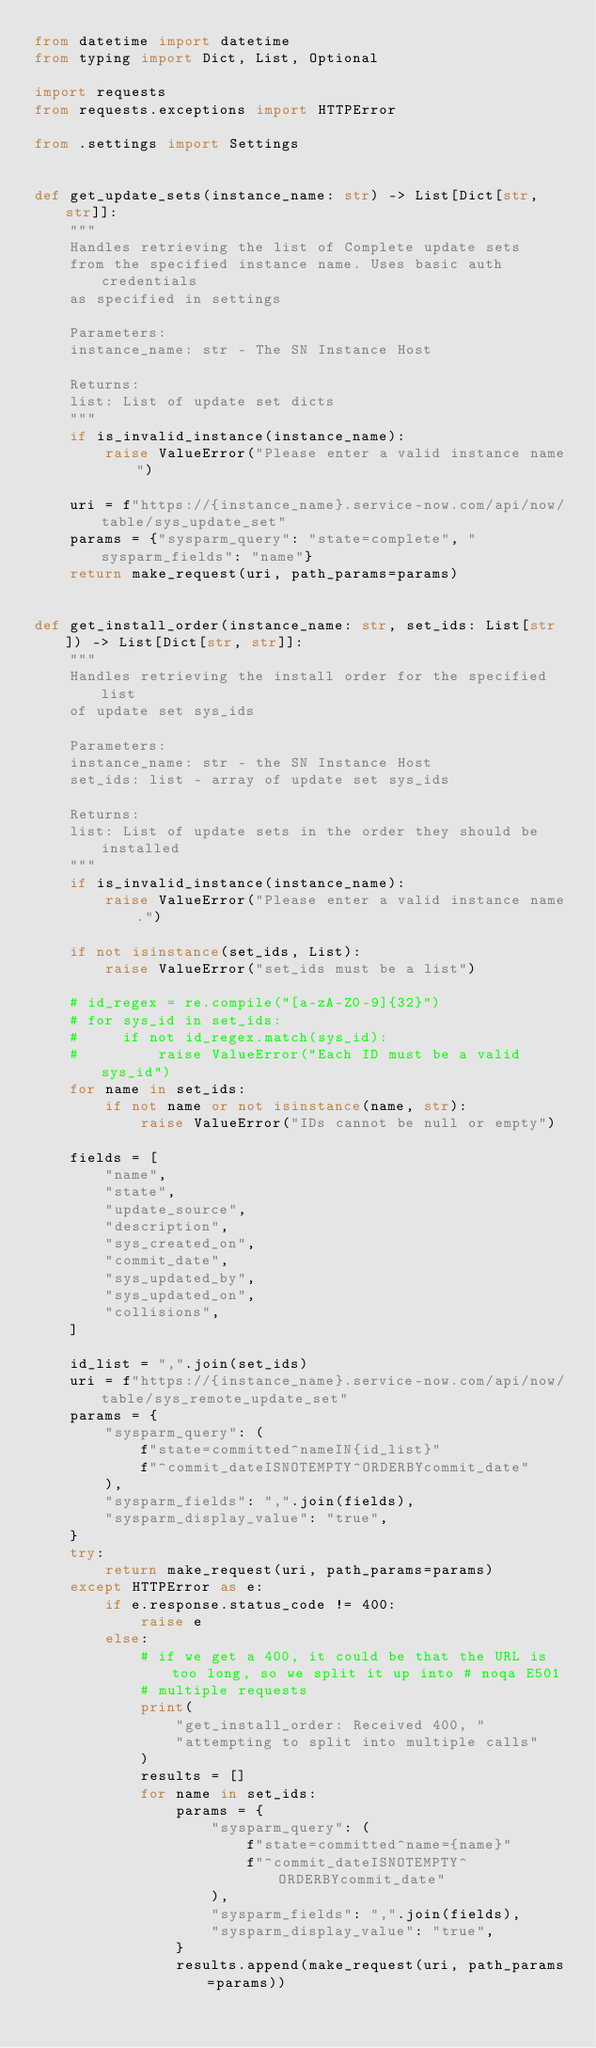Convert code to text. <code><loc_0><loc_0><loc_500><loc_500><_Python_>from datetime import datetime
from typing import Dict, List, Optional

import requests
from requests.exceptions import HTTPError

from .settings import Settings


def get_update_sets(instance_name: str) -> List[Dict[str, str]]:
    """
    Handles retrieving the list of Complete update sets
    from the specified instance name. Uses basic auth credentials
    as specified in settings

    Parameters:
    instance_name: str - The SN Instance Host

    Returns:
    list: List of update set dicts
    """
    if is_invalid_instance(instance_name):
        raise ValueError("Please enter a valid instance name")

    uri = f"https://{instance_name}.service-now.com/api/now/table/sys_update_set"
    params = {"sysparm_query": "state=complete", "sysparm_fields": "name"}
    return make_request(uri, path_params=params)


def get_install_order(instance_name: str, set_ids: List[str]) -> List[Dict[str, str]]:
    """
    Handles retrieving the install order for the specified list
    of update set sys_ids

    Parameters:
    instance_name: str - the SN Instance Host
    set_ids: list - array of update set sys_ids

    Returns:
    list: List of update sets in the order they should be installed
    """
    if is_invalid_instance(instance_name):
        raise ValueError("Please enter a valid instance name.")

    if not isinstance(set_ids, List):
        raise ValueError("set_ids must be a list")

    # id_regex = re.compile("[a-zA-Z0-9]{32}")
    # for sys_id in set_ids:
    #     if not id_regex.match(sys_id):
    #         raise ValueError("Each ID must be a valid sys_id")
    for name in set_ids:
        if not name or not isinstance(name, str):
            raise ValueError("IDs cannot be null or empty")

    fields = [
        "name",
        "state",
        "update_source",
        "description",
        "sys_created_on",
        "commit_date",
        "sys_updated_by",
        "sys_updated_on",
        "collisions",
    ]

    id_list = ",".join(set_ids)
    uri = f"https://{instance_name}.service-now.com/api/now/table/sys_remote_update_set"
    params = {
        "sysparm_query": (
            f"state=committed^nameIN{id_list}"
            f"^commit_dateISNOTEMPTY^ORDERBYcommit_date"
        ),
        "sysparm_fields": ",".join(fields),
        "sysparm_display_value": "true",
    }
    try:
        return make_request(uri, path_params=params)
    except HTTPError as e:
        if e.response.status_code != 400:
            raise e
        else:
            # if we get a 400, it could be that the URL is too long, so we split it up into # noqa E501
            # multiple requests
            print(
                "get_install_order: Received 400, "
                "attempting to split into multiple calls"
            )
            results = []
            for name in set_ids:
                params = {
                    "sysparm_query": (
                        f"state=committed^name={name}"
                        f"^commit_dateISNOTEMPTY^ORDERBYcommit_date"
                    ),
                    "sysparm_fields": ",".join(fields),
                    "sysparm_display_value": "true",
                }
                results.append(make_request(uri, path_params=params))
</code> 